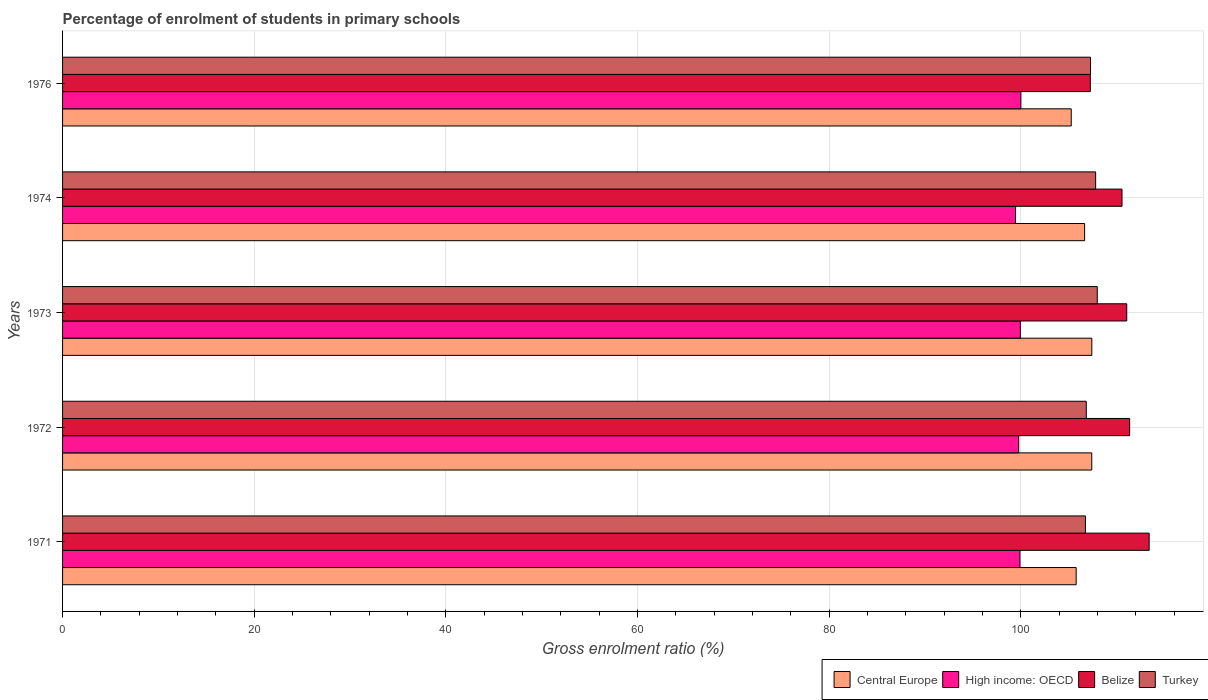How many different coloured bars are there?
Offer a terse response. 4. How many groups of bars are there?
Offer a terse response. 5. Are the number of bars per tick equal to the number of legend labels?
Ensure brevity in your answer.  Yes. How many bars are there on the 1st tick from the bottom?
Your answer should be compact. 4. What is the label of the 1st group of bars from the top?
Keep it short and to the point. 1976. What is the percentage of students enrolled in primary schools in Central Europe in 1976?
Your response must be concise. 105.27. Across all years, what is the maximum percentage of students enrolled in primary schools in Turkey?
Your answer should be very brief. 107.98. Across all years, what is the minimum percentage of students enrolled in primary schools in High income: OECD?
Your response must be concise. 99.45. In which year was the percentage of students enrolled in primary schools in Turkey minimum?
Give a very brief answer. 1971. What is the total percentage of students enrolled in primary schools in Turkey in the graph?
Provide a short and direct response. 536.66. What is the difference between the percentage of students enrolled in primary schools in Turkey in 1972 and that in 1976?
Ensure brevity in your answer.  -0.44. What is the difference between the percentage of students enrolled in primary schools in High income: OECD in 1973 and the percentage of students enrolled in primary schools in Turkey in 1976?
Your response must be concise. -7.33. What is the average percentage of students enrolled in primary schools in Turkey per year?
Offer a very short reply. 107.33. In the year 1972, what is the difference between the percentage of students enrolled in primary schools in Belize and percentage of students enrolled in primary schools in High income: OECD?
Give a very brief answer. 11.58. What is the ratio of the percentage of students enrolled in primary schools in High income: OECD in 1974 to that in 1976?
Provide a succinct answer. 0.99. Is the difference between the percentage of students enrolled in primary schools in Belize in 1972 and 1973 greater than the difference between the percentage of students enrolled in primary schools in High income: OECD in 1972 and 1973?
Provide a short and direct response. Yes. What is the difference between the highest and the second highest percentage of students enrolled in primary schools in Turkey?
Offer a terse response. 0.17. What is the difference between the highest and the lowest percentage of students enrolled in primary schools in High income: OECD?
Your answer should be very brief. 0.56. In how many years, is the percentage of students enrolled in primary schools in Central Europe greater than the average percentage of students enrolled in primary schools in Central Europe taken over all years?
Your answer should be compact. 3. Is the sum of the percentage of students enrolled in primary schools in High income: OECD in 1973 and 1974 greater than the maximum percentage of students enrolled in primary schools in Belize across all years?
Offer a terse response. Yes. What does the 4th bar from the top in 1973 represents?
Make the answer very short. Central Europe. What does the 4th bar from the bottom in 1974 represents?
Your answer should be compact. Turkey. Is it the case that in every year, the sum of the percentage of students enrolled in primary schools in Central Europe and percentage of students enrolled in primary schools in Turkey is greater than the percentage of students enrolled in primary schools in High income: OECD?
Make the answer very short. Yes. Are all the bars in the graph horizontal?
Offer a terse response. Yes. How many years are there in the graph?
Provide a short and direct response. 5. What is the difference between two consecutive major ticks on the X-axis?
Offer a terse response. 20. Are the values on the major ticks of X-axis written in scientific E-notation?
Provide a short and direct response. No. Does the graph contain any zero values?
Give a very brief answer. No. Does the graph contain grids?
Offer a very short reply. Yes. How many legend labels are there?
Provide a succinct answer. 4. How are the legend labels stacked?
Provide a succinct answer. Horizontal. What is the title of the graph?
Keep it short and to the point. Percentage of enrolment of students in primary schools. Does "Luxembourg" appear as one of the legend labels in the graph?
Your answer should be very brief. No. What is the label or title of the X-axis?
Your answer should be compact. Gross enrolment ratio (%). What is the label or title of the Y-axis?
Offer a terse response. Years. What is the Gross enrolment ratio (%) of Central Europe in 1971?
Provide a succinct answer. 105.78. What is the Gross enrolment ratio (%) in High income: OECD in 1971?
Make the answer very short. 99.91. What is the Gross enrolment ratio (%) in Belize in 1971?
Give a very brief answer. 113.4. What is the Gross enrolment ratio (%) in Turkey in 1971?
Offer a terse response. 106.75. What is the Gross enrolment ratio (%) of Central Europe in 1972?
Give a very brief answer. 107.41. What is the Gross enrolment ratio (%) of High income: OECD in 1972?
Provide a short and direct response. 99.78. What is the Gross enrolment ratio (%) of Belize in 1972?
Your answer should be compact. 111.36. What is the Gross enrolment ratio (%) in Turkey in 1972?
Your answer should be very brief. 106.84. What is the Gross enrolment ratio (%) in Central Europe in 1973?
Provide a succinct answer. 107.41. What is the Gross enrolment ratio (%) of High income: OECD in 1973?
Keep it short and to the point. 99.96. What is the Gross enrolment ratio (%) in Belize in 1973?
Provide a short and direct response. 111.06. What is the Gross enrolment ratio (%) in Turkey in 1973?
Your answer should be very brief. 107.98. What is the Gross enrolment ratio (%) of Central Europe in 1974?
Ensure brevity in your answer.  106.66. What is the Gross enrolment ratio (%) of High income: OECD in 1974?
Offer a very short reply. 99.45. What is the Gross enrolment ratio (%) in Belize in 1974?
Your answer should be very brief. 110.57. What is the Gross enrolment ratio (%) of Turkey in 1974?
Make the answer very short. 107.81. What is the Gross enrolment ratio (%) in Central Europe in 1976?
Your answer should be compact. 105.27. What is the Gross enrolment ratio (%) of High income: OECD in 1976?
Ensure brevity in your answer.  100.01. What is the Gross enrolment ratio (%) in Belize in 1976?
Make the answer very short. 107.26. What is the Gross enrolment ratio (%) in Turkey in 1976?
Offer a terse response. 107.28. Across all years, what is the maximum Gross enrolment ratio (%) of Central Europe?
Your response must be concise. 107.41. Across all years, what is the maximum Gross enrolment ratio (%) in High income: OECD?
Offer a terse response. 100.01. Across all years, what is the maximum Gross enrolment ratio (%) of Belize?
Ensure brevity in your answer.  113.4. Across all years, what is the maximum Gross enrolment ratio (%) of Turkey?
Your response must be concise. 107.98. Across all years, what is the minimum Gross enrolment ratio (%) in Central Europe?
Keep it short and to the point. 105.27. Across all years, what is the minimum Gross enrolment ratio (%) in High income: OECD?
Your answer should be compact. 99.45. Across all years, what is the minimum Gross enrolment ratio (%) in Belize?
Ensure brevity in your answer.  107.26. Across all years, what is the minimum Gross enrolment ratio (%) in Turkey?
Provide a short and direct response. 106.75. What is the total Gross enrolment ratio (%) of Central Europe in the graph?
Your answer should be compact. 532.53. What is the total Gross enrolment ratio (%) of High income: OECD in the graph?
Provide a short and direct response. 499.12. What is the total Gross enrolment ratio (%) of Belize in the graph?
Your answer should be very brief. 553.65. What is the total Gross enrolment ratio (%) of Turkey in the graph?
Ensure brevity in your answer.  536.66. What is the difference between the Gross enrolment ratio (%) in Central Europe in 1971 and that in 1972?
Offer a very short reply. -1.63. What is the difference between the Gross enrolment ratio (%) in High income: OECD in 1971 and that in 1972?
Provide a short and direct response. 0.13. What is the difference between the Gross enrolment ratio (%) of Belize in 1971 and that in 1972?
Ensure brevity in your answer.  2.04. What is the difference between the Gross enrolment ratio (%) of Turkey in 1971 and that in 1972?
Provide a short and direct response. -0.09. What is the difference between the Gross enrolment ratio (%) in Central Europe in 1971 and that in 1973?
Your answer should be very brief. -1.63. What is the difference between the Gross enrolment ratio (%) of High income: OECD in 1971 and that in 1973?
Offer a terse response. -0.04. What is the difference between the Gross enrolment ratio (%) in Belize in 1971 and that in 1973?
Your response must be concise. 2.34. What is the difference between the Gross enrolment ratio (%) of Turkey in 1971 and that in 1973?
Provide a succinct answer. -1.24. What is the difference between the Gross enrolment ratio (%) in Central Europe in 1971 and that in 1974?
Give a very brief answer. -0.88. What is the difference between the Gross enrolment ratio (%) in High income: OECD in 1971 and that in 1974?
Offer a very short reply. 0.46. What is the difference between the Gross enrolment ratio (%) in Belize in 1971 and that in 1974?
Your response must be concise. 2.83. What is the difference between the Gross enrolment ratio (%) of Turkey in 1971 and that in 1974?
Ensure brevity in your answer.  -1.07. What is the difference between the Gross enrolment ratio (%) in Central Europe in 1971 and that in 1976?
Give a very brief answer. 0.52. What is the difference between the Gross enrolment ratio (%) in High income: OECD in 1971 and that in 1976?
Provide a short and direct response. -0.1. What is the difference between the Gross enrolment ratio (%) in Belize in 1971 and that in 1976?
Offer a very short reply. 6.14. What is the difference between the Gross enrolment ratio (%) of Turkey in 1971 and that in 1976?
Your answer should be compact. -0.53. What is the difference between the Gross enrolment ratio (%) of Central Europe in 1972 and that in 1973?
Provide a succinct answer. -0.01. What is the difference between the Gross enrolment ratio (%) in High income: OECD in 1972 and that in 1973?
Provide a succinct answer. -0.17. What is the difference between the Gross enrolment ratio (%) in Belize in 1972 and that in 1973?
Ensure brevity in your answer.  0.3. What is the difference between the Gross enrolment ratio (%) of Turkey in 1972 and that in 1973?
Your response must be concise. -1.15. What is the difference between the Gross enrolment ratio (%) in Central Europe in 1972 and that in 1974?
Provide a short and direct response. 0.74. What is the difference between the Gross enrolment ratio (%) in High income: OECD in 1972 and that in 1974?
Make the answer very short. 0.33. What is the difference between the Gross enrolment ratio (%) in Belize in 1972 and that in 1974?
Make the answer very short. 0.8. What is the difference between the Gross enrolment ratio (%) in Turkey in 1972 and that in 1974?
Make the answer very short. -0.98. What is the difference between the Gross enrolment ratio (%) of Central Europe in 1972 and that in 1976?
Your answer should be compact. 2.14. What is the difference between the Gross enrolment ratio (%) of High income: OECD in 1972 and that in 1976?
Your answer should be very brief. -0.23. What is the difference between the Gross enrolment ratio (%) of Belize in 1972 and that in 1976?
Your answer should be compact. 4.11. What is the difference between the Gross enrolment ratio (%) in Turkey in 1972 and that in 1976?
Give a very brief answer. -0.44. What is the difference between the Gross enrolment ratio (%) of Central Europe in 1973 and that in 1974?
Offer a very short reply. 0.75. What is the difference between the Gross enrolment ratio (%) of High income: OECD in 1973 and that in 1974?
Provide a short and direct response. 0.5. What is the difference between the Gross enrolment ratio (%) in Belize in 1973 and that in 1974?
Provide a short and direct response. 0.5. What is the difference between the Gross enrolment ratio (%) in Turkey in 1973 and that in 1974?
Provide a short and direct response. 0.17. What is the difference between the Gross enrolment ratio (%) in Central Europe in 1973 and that in 1976?
Offer a very short reply. 2.15. What is the difference between the Gross enrolment ratio (%) in High income: OECD in 1973 and that in 1976?
Your answer should be very brief. -0.06. What is the difference between the Gross enrolment ratio (%) of Belize in 1973 and that in 1976?
Give a very brief answer. 3.8. What is the difference between the Gross enrolment ratio (%) of Turkey in 1973 and that in 1976?
Offer a terse response. 0.7. What is the difference between the Gross enrolment ratio (%) of Central Europe in 1974 and that in 1976?
Offer a very short reply. 1.4. What is the difference between the Gross enrolment ratio (%) in High income: OECD in 1974 and that in 1976?
Offer a very short reply. -0.56. What is the difference between the Gross enrolment ratio (%) in Belize in 1974 and that in 1976?
Your answer should be compact. 3.31. What is the difference between the Gross enrolment ratio (%) of Turkey in 1974 and that in 1976?
Your answer should be very brief. 0.53. What is the difference between the Gross enrolment ratio (%) of Central Europe in 1971 and the Gross enrolment ratio (%) of High income: OECD in 1972?
Ensure brevity in your answer.  6. What is the difference between the Gross enrolment ratio (%) of Central Europe in 1971 and the Gross enrolment ratio (%) of Belize in 1972?
Your response must be concise. -5.58. What is the difference between the Gross enrolment ratio (%) in Central Europe in 1971 and the Gross enrolment ratio (%) in Turkey in 1972?
Offer a terse response. -1.06. What is the difference between the Gross enrolment ratio (%) of High income: OECD in 1971 and the Gross enrolment ratio (%) of Belize in 1972?
Offer a terse response. -11.45. What is the difference between the Gross enrolment ratio (%) of High income: OECD in 1971 and the Gross enrolment ratio (%) of Turkey in 1972?
Your answer should be very brief. -6.92. What is the difference between the Gross enrolment ratio (%) in Belize in 1971 and the Gross enrolment ratio (%) in Turkey in 1972?
Your response must be concise. 6.56. What is the difference between the Gross enrolment ratio (%) in Central Europe in 1971 and the Gross enrolment ratio (%) in High income: OECD in 1973?
Your answer should be very brief. 5.83. What is the difference between the Gross enrolment ratio (%) of Central Europe in 1971 and the Gross enrolment ratio (%) of Belize in 1973?
Your answer should be compact. -5.28. What is the difference between the Gross enrolment ratio (%) of Central Europe in 1971 and the Gross enrolment ratio (%) of Turkey in 1973?
Provide a short and direct response. -2.2. What is the difference between the Gross enrolment ratio (%) of High income: OECD in 1971 and the Gross enrolment ratio (%) of Belize in 1973?
Ensure brevity in your answer.  -11.15. What is the difference between the Gross enrolment ratio (%) of High income: OECD in 1971 and the Gross enrolment ratio (%) of Turkey in 1973?
Your answer should be very brief. -8.07. What is the difference between the Gross enrolment ratio (%) of Belize in 1971 and the Gross enrolment ratio (%) of Turkey in 1973?
Your answer should be very brief. 5.42. What is the difference between the Gross enrolment ratio (%) of Central Europe in 1971 and the Gross enrolment ratio (%) of High income: OECD in 1974?
Keep it short and to the point. 6.33. What is the difference between the Gross enrolment ratio (%) in Central Europe in 1971 and the Gross enrolment ratio (%) in Belize in 1974?
Provide a short and direct response. -4.78. What is the difference between the Gross enrolment ratio (%) of Central Europe in 1971 and the Gross enrolment ratio (%) of Turkey in 1974?
Your answer should be compact. -2.03. What is the difference between the Gross enrolment ratio (%) in High income: OECD in 1971 and the Gross enrolment ratio (%) in Belize in 1974?
Make the answer very short. -10.65. What is the difference between the Gross enrolment ratio (%) of High income: OECD in 1971 and the Gross enrolment ratio (%) of Turkey in 1974?
Offer a terse response. -7.9. What is the difference between the Gross enrolment ratio (%) of Belize in 1971 and the Gross enrolment ratio (%) of Turkey in 1974?
Your response must be concise. 5.59. What is the difference between the Gross enrolment ratio (%) in Central Europe in 1971 and the Gross enrolment ratio (%) in High income: OECD in 1976?
Provide a short and direct response. 5.77. What is the difference between the Gross enrolment ratio (%) of Central Europe in 1971 and the Gross enrolment ratio (%) of Belize in 1976?
Your answer should be very brief. -1.47. What is the difference between the Gross enrolment ratio (%) of Central Europe in 1971 and the Gross enrolment ratio (%) of Turkey in 1976?
Your response must be concise. -1.5. What is the difference between the Gross enrolment ratio (%) of High income: OECD in 1971 and the Gross enrolment ratio (%) of Belize in 1976?
Make the answer very short. -7.34. What is the difference between the Gross enrolment ratio (%) in High income: OECD in 1971 and the Gross enrolment ratio (%) in Turkey in 1976?
Provide a short and direct response. -7.37. What is the difference between the Gross enrolment ratio (%) in Belize in 1971 and the Gross enrolment ratio (%) in Turkey in 1976?
Provide a succinct answer. 6.12. What is the difference between the Gross enrolment ratio (%) of Central Europe in 1972 and the Gross enrolment ratio (%) of High income: OECD in 1973?
Offer a very short reply. 7.45. What is the difference between the Gross enrolment ratio (%) of Central Europe in 1972 and the Gross enrolment ratio (%) of Belize in 1973?
Ensure brevity in your answer.  -3.65. What is the difference between the Gross enrolment ratio (%) in Central Europe in 1972 and the Gross enrolment ratio (%) in Turkey in 1973?
Provide a short and direct response. -0.57. What is the difference between the Gross enrolment ratio (%) of High income: OECD in 1972 and the Gross enrolment ratio (%) of Belize in 1973?
Make the answer very short. -11.28. What is the difference between the Gross enrolment ratio (%) of High income: OECD in 1972 and the Gross enrolment ratio (%) of Turkey in 1973?
Ensure brevity in your answer.  -8.2. What is the difference between the Gross enrolment ratio (%) of Belize in 1972 and the Gross enrolment ratio (%) of Turkey in 1973?
Keep it short and to the point. 3.38. What is the difference between the Gross enrolment ratio (%) of Central Europe in 1972 and the Gross enrolment ratio (%) of High income: OECD in 1974?
Make the answer very short. 7.95. What is the difference between the Gross enrolment ratio (%) of Central Europe in 1972 and the Gross enrolment ratio (%) of Belize in 1974?
Offer a terse response. -3.16. What is the difference between the Gross enrolment ratio (%) of Central Europe in 1972 and the Gross enrolment ratio (%) of Turkey in 1974?
Your answer should be very brief. -0.4. What is the difference between the Gross enrolment ratio (%) in High income: OECD in 1972 and the Gross enrolment ratio (%) in Belize in 1974?
Ensure brevity in your answer.  -10.78. What is the difference between the Gross enrolment ratio (%) in High income: OECD in 1972 and the Gross enrolment ratio (%) in Turkey in 1974?
Provide a succinct answer. -8.03. What is the difference between the Gross enrolment ratio (%) of Belize in 1972 and the Gross enrolment ratio (%) of Turkey in 1974?
Provide a succinct answer. 3.55. What is the difference between the Gross enrolment ratio (%) of Central Europe in 1972 and the Gross enrolment ratio (%) of High income: OECD in 1976?
Your answer should be very brief. 7.4. What is the difference between the Gross enrolment ratio (%) in Central Europe in 1972 and the Gross enrolment ratio (%) in Belize in 1976?
Make the answer very short. 0.15. What is the difference between the Gross enrolment ratio (%) in Central Europe in 1972 and the Gross enrolment ratio (%) in Turkey in 1976?
Your answer should be compact. 0.13. What is the difference between the Gross enrolment ratio (%) in High income: OECD in 1972 and the Gross enrolment ratio (%) in Belize in 1976?
Keep it short and to the point. -7.47. What is the difference between the Gross enrolment ratio (%) of High income: OECD in 1972 and the Gross enrolment ratio (%) of Turkey in 1976?
Keep it short and to the point. -7.5. What is the difference between the Gross enrolment ratio (%) in Belize in 1972 and the Gross enrolment ratio (%) in Turkey in 1976?
Provide a succinct answer. 4.08. What is the difference between the Gross enrolment ratio (%) in Central Europe in 1973 and the Gross enrolment ratio (%) in High income: OECD in 1974?
Provide a succinct answer. 7.96. What is the difference between the Gross enrolment ratio (%) of Central Europe in 1973 and the Gross enrolment ratio (%) of Belize in 1974?
Offer a very short reply. -3.15. What is the difference between the Gross enrolment ratio (%) of Central Europe in 1973 and the Gross enrolment ratio (%) of Turkey in 1974?
Your answer should be very brief. -0.4. What is the difference between the Gross enrolment ratio (%) of High income: OECD in 1973 and the Gross enrolment ratio (%) of Belize in 1974?
Make the answer very short. -10.61. What is the difference between the Gross enrolment ratio (%) of High income: OECD in 1973 and the Gross enrolment ratio (%) of Turkey in 1974?
Your answer should be compact. -7.86. What is the difference between the Gross enrolment ratio (%) in Belize in 1973 and the Gross enrolment ratio (%) in Turkey in 1974?
Give a very brief answer. 3.25. What is the difference between the Gross enrolment ratio (%) of Central Europe in 1973 and the Gross enrolment ratio (%) of High income: OECD in 1976?
Your response must be concise. 7.4. What is the difference between the Gross enrolment ratio (%) in Central Europe in 1973 and the Gross enrolment ratio (%) in Belize in 1976?
Give a very brief answer. 0.16. What is the difference between the Gross enrolment ratio (%) of Central Europe in 1973 and the Gross enrolment ratio (%) of Turkey in 1976?
Keep it short and to the point. 0.13. What is the difference between the Gross enrolment ratio (%) of High income: OECD in 1973 and the Gross enrolment ratio (%) of Belize in 1976?
Give a very brief answer. -7.3. What is the difference between the Gross enrolment ratio (%) in High income: OECD in 1973 and the Gross enrolment ratio (%) in Turkey in 1976?
Provide a succinct answer. -7.33. What is the difference between the Gross enrolment ratio (%) of Belize in 1973 and the Gross enrolment ratio (%) of Turkey in 1976?
Your answer should be compact. 3.78. What is the difference between the Gross enrolment ratio (%) in Central Europe in 1974 and the Gross enrolment ratio (%) in High income: OECD in 1976?
Make the answer very short. 6.65. What is the difference between the Gross enrolment ratio (%) of Central Europe in 1974 and the Gross enrolment ratio (%) of Belize in 1976?
Your answer should be compact. -0.59. What is the difference between the Gross enrolment ratio (%) of Central Europe in 1974 and the Gross enrolment ratio (%) of Turkey in 1976?
Provide a short and direct response. -0.62. What is the difference between the Gross enrolment ratio (%) in High income: OECD in 1974 and the Gross enrolment ratio (%) in Belize in 1976?
Your answer should be very brief. -7.8. What is the difference between the Gross enrolment ratio (%) in High income: OECD in 1974 and the Gross enrolment ratio (%) in Turkey in 1976?
Provide a short and direct response. -7.83. What is the difference between the Gross enrolment ratio (%) in Belize in 1974 and the Gross enrolment ratio (%) in Turkey in 1976?
Keep it short and to the point. 3.28. What is the average Gross enrolment ratio (%) of Central Europe per year?
Ensure brevity in your answer.  106.51. What is the average Gross enrolment ratio (%) in High income: OECD per year?
Offer a terse response. 99.82. What is the average Gross enrolment ratio (%) of Belize per year?
Give a very brief answer. 110.73. What is the average Gross enrolment ratio (%) of Turkey per year?
Ensure brevity in your answer.  107.33. In the year 1971, what is the difference between the Gross enrolment ratio (%) of Central Europe and Gross enrolment ratio (%) of High income: OECD?
Provide a short and direct response. 5.87. In the year 1971, what is the difference between the Gross enrolment ratio (%) in Central Europe and Gross enrolment ratio (%) in Belize?
Keep it short and to the point. -7.62. In the year 1971, what is the difference between the Gross enrolment ratio (%) of Central Europe and Gross enrolment ratio (%) of Turkey?
Offer a very short reply. -0.96. In the year 1971, what is the difference between the Gross enrolment ratio (%) of High income: OECD and Gross enrolment ratio (%) of Belize?
Your response must be concise. -13.48. In the year 1971, what is the difference between the Gross enrolment ratio (%) in High income: OECD and Gross enrolment ratio (%) in Turkey?
Ensure brevity in your answer.  -6.83. In the year 1971, what is the difference between the Gross enrolment ratio (%) in Belize and Gross enrolment ratio (%) in Turkey?
Offer a very short reply. 6.65. In the year 1972, what is the difference between the Gross enrolment ratio (%) of Central Europe and Gross enrolment ratio (%) of High income: OECD?
Your response must be concise. 7.63. In the year 1972, what is the difference between the Gross enrolment ratio (%) of Central Europe and Gross enrolment ratio (%) of Belize?
Your answer should be compact. -3.96. In the year 1972, what is the difference between the Gross enrolment ratio (%) in Central Europe and Gross enrolment ratio (%) in Turkey?
Provide a short and direct response. 0.57. In the year 1972, what is the difference between the Gross enrolment ratio (%) in High income: OECD and Gross enrolment ratio (%) in Belize?
Offer a terse response. -11.58. In the year 1972, what is the difference between the Gross enrolment ratio (%) in High income: OECD and Gross enrolment ratio (%) in Turkey?
Provide a short and direct response. -7.05. In the year 1972, what is the difference between the Gross enrolment ratio (%) of Belize and Gross enrolment ratio (%) of Turkey?
Provide a succinct answer. 4.53. In the year 1973, what is the difference between the Gross enrolment ratio (%) of Central Europe and Gross enrolment ratio (%) of High income: OECD?
Your response must be concise. 7.46. In the year 1973, what is the difference between the Gross enrolment ratio (%) in Central Europe and Gross enrolment ratio (%) in Belize?
Provide a short and direct response. -3.65. In the year 1973, what is the difference between the Gross enrolment ratio (%) in Central Europe and Gross enrolment ratio (%) in Turkey?
Offer a very short reply. -0.57. In the year 1973, what is the difference between the Gross enrolment ratio (%) of High income: OECD and Gross enrolment ratio (%) of Belize?
Keep it short and to the point. -11.11. In the year 1973, what is the difference between the Gross enrolment ratio (%) in High income: OECD and Gross enrolment ratio (%) in Turkey?
Provide a short and direct response. -8.03. In the year 1973, what is the difference between the Gross enrolment ratio (%) of Belize and Gross enrolment ratio (%) of Turkey?
Your answer should be compact. 3.08. In the year 1974, what is the difference between the Gross enrolment ratio (%) in Central Europe and Gross enrolment ratio (%) in High income: OECD?
Make the answer very short. 7.21. In the year 1974, what is the difference between the Gross enrolment ratio (%) in Central Europe and Gross enrolment ratio (%) in Belize?
Offer a terse response. -3.9. In the year 1974, what is the difference between the Gross enrolment ratio (%) of Central Europe and Gross enrolment ratio (%) of Turkey?
Ensure brevity in your answer.  -1.15. In the year 1974, what is the difference between the Gross enrolment ratio (%) of High income: OECD and Gross enrolment ratio (%) of Belize?
Your answer should be compact. -11.11. In the year 1974, what is the difference between the Gross enrolment ratio (%) of High income: OECD and Gross enrolment ratio (%) of Turkey?
Offer a terse response. -8.36. In the year 1974, what is the difference between the Gross enrolment ratio (%) of Belize and Gross enrolment ratio (%) of Turkey?
Ensure brevity in your answer.  2.75. In the year 1976, what is the difference between the Gross enrolment ratio (%) of Central Europe and Gross enrolment ratio (%) of High income: OECD?
Ensure brevity in your answer.  5.25. In the year 1976, what is the difference between the Gross enrolment ratio (%) in Central Europe and Gross enrolment ratio (%) in Belize?
Provide a succinct answer. -1.99. In the year 1976, what is the difference between the Gross enrolment ratio (%) in Central Europe and Gross enrolment ratio (%) in Turkey?
Make the answer very short. -2.01. In the year 1976, what is the difference between the Gross enrolment ratio (%) in High income: OECD and Gross enrolment ratio (%) in Belize?
Your response must be concise. -7.25. In the year 1976, what is the difference between the Gross enrolment ratio (%) in High income: OECD and Gross enrolment ratio (%) in Turkey?
Keep it short and to the point. -7.27. In the year 1976, what is the difference between the Gross enrolment ratio (%) of Belize and Gross enrolment ratio (%) of Turkey?
Give a very brief answer. -0.02. What is the ratio of the Gross enrolment ratio (%) in Central Europe in 1971 to that in 1972?
Offer a terse response. 0.98. What is the ratio of the Gross enrolment ratio (%) in High income: OECD in 1971 to that in 1972?
Provide a short and direct response. 1. What is the ratio of the Gross enrolment ratio (%) of Belize in 1971 to that in 1972?
Offer a terse response. 1.02. What is the ratio of the Gross enrolment ratio (%) in High income: OECD in 1971 to that in 1973?
Your answer should be compact. 1. What is the ratio of the Gross enrolment ratio (%) of Belize in 1971 to that in 1973?
Keep it short and to the point. 1.02. What is the ratio of the Gross enrolment ratio (%) in Turkey in 1971 to that in 1973?
Make the answer very short. 0.99. What is the ratio of the Gross enrolment ratio (%) of Belize in 1971 to that in 1974?
Offer a very short reply. 1.03. What is the ratio of the Gross enrolment ratio (%) in High income: OECD in 1971 to that in 1976?
Ensure brevity in your answer.  1. What is the ratio of the Gross enrolment ratio (%) of Belize in 1971 to that in 1976?
Ensure brevity in your answer.  1.06. What is the ratio of the Gross enrolment ratio (%) in Belize in 1972 to that in 1973?
Your response must be concise. 1. What is the ratio of the Gross enrolment ratio (%) of Belize in 1972 to that in 1974?
Offer a terse response. 1.01. What is the ratio of the Gross enrolment ratio (%) of Turkey in 1972 to that in 1974?
Your answer should be very brief. 0.99. What is the ratio of the Gross enrolment ratio (%) of Central Europe in 1972 to that in 1976?
Keep it short and to the point. 1.02. What is the ratio of the Gross enrolment ratio (%) in Belize in 1972 to that in 1976?
Make the answer very short. 1.04. What is the ratio of the Gross enrolment ratio (%) of Turkey in 1972 to that in 1976?
Make the answer very short. 1. What is the ratio of the Gross enrolment ratio (%) in Turkey in 1973 to that in 1974?
Offer a very short reply. 1. What is the ratio of the Gross enrolment ratio (%) of Central Europe in 1973 to that in 1976?
Provide a succinct answer. 1.02. What is the ratio of the Gross enrolment ratio (%) in Belize in 1973 to that in 1976?
Provide a succinct answer. 1.04. What is the ratio of the Gross enrolment ratio (%) in Turkey in 1973 to that in 1976?
Keep it short and to the point. 1.01. What is the ratio of the Gross enrolment ratio (%) of Central Europe in 1974 to that in 1976?
Your answer should be very brief. 1.01. What is the ratio of the Gross enrolment ratio (%) of Belize in 1974 to that in 1976?
Your answer should be compact. 1.03. What is the difference between the highest and the second highest Gross enrolment ratio (%) of Central Europe?
Offer a very short reply. 0.01. What is the difference between the highest and the second highest Gross enrolment ratio (%) in High income: OECD?
Offer a very short reply. 0.06. What is the difference between the highest and the second highest Gross enrolment ratio (%) in Belize?
Keep it short and to the point. 2.04. What is the difference between the highest and the second highest Gross enrolment ratio (%) of Turkey?
Provide a short and direct response. 0.17. What is the difference between the highest and the lowest Gross enrolment ratio (%) of Central Europe?
Make the answer very short. 2.15. What is the difference between the highest and the lowest Gross enrolment ratio (%) of High income: OECD?
Provide a short and direct response. 0.56. What is the difference between the highest and the lowest Gross enrolment ratio (%) in Belize?
Keep it short and to the point. 6.14. What is the difference between the highest and the lowest Gross enrolment ratio (%) of Turkey?
Make the answer very short. 1.24. 